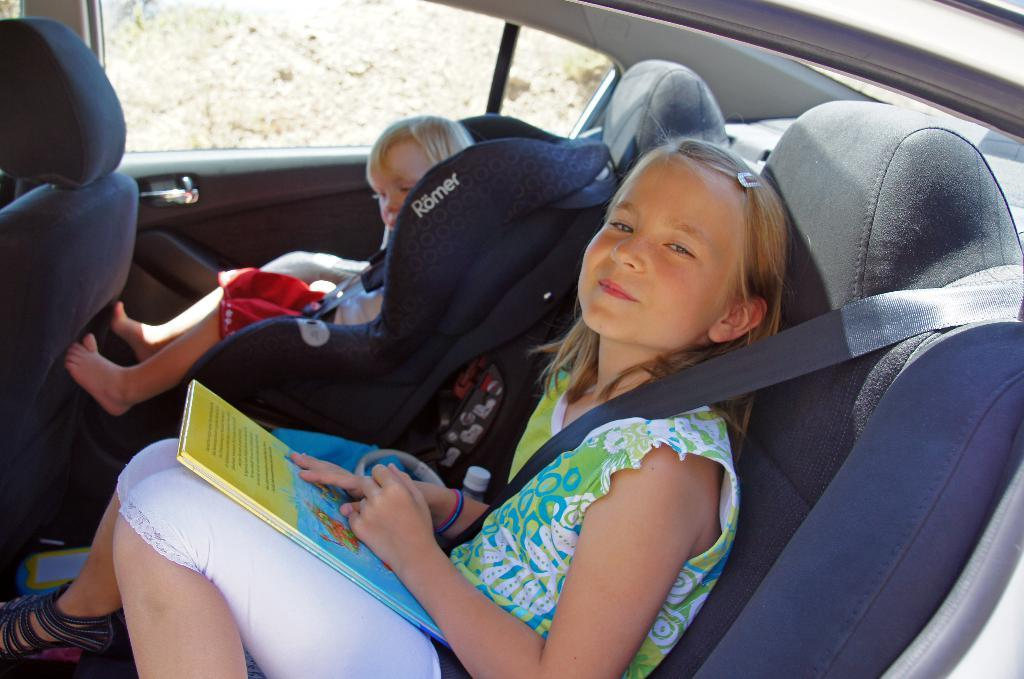What are the people in the image doing? There are two people sitting on a car in the image. Can you describe the girl in the image? One of them is a girl, and she is wearing a seatbelt. What is the girl's expression in the image? The girl is smiling in the image. What type of pen is the girl holding in the image? There is no pen present in the image; the girl is sitting on a car and wearing a seatbelt. 